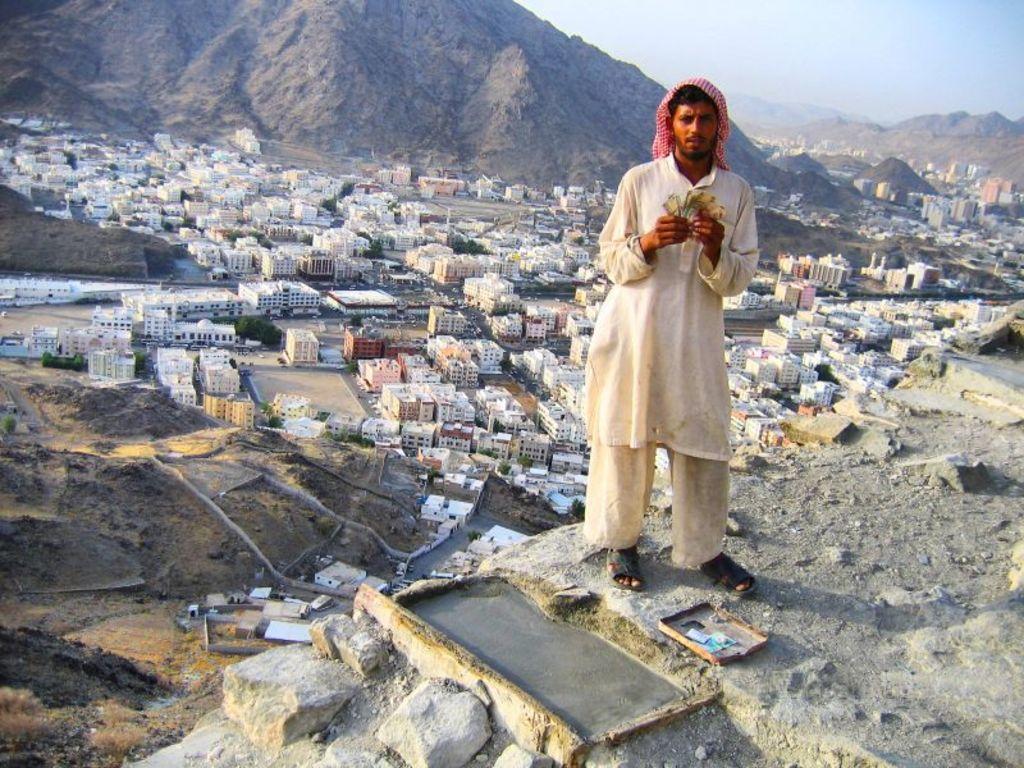In one or two sentences, can you explain what this image depicts? In this image there is a person standing. He is holding an object. There are buildings on the land. Background there are hills. Right top there is sky. 